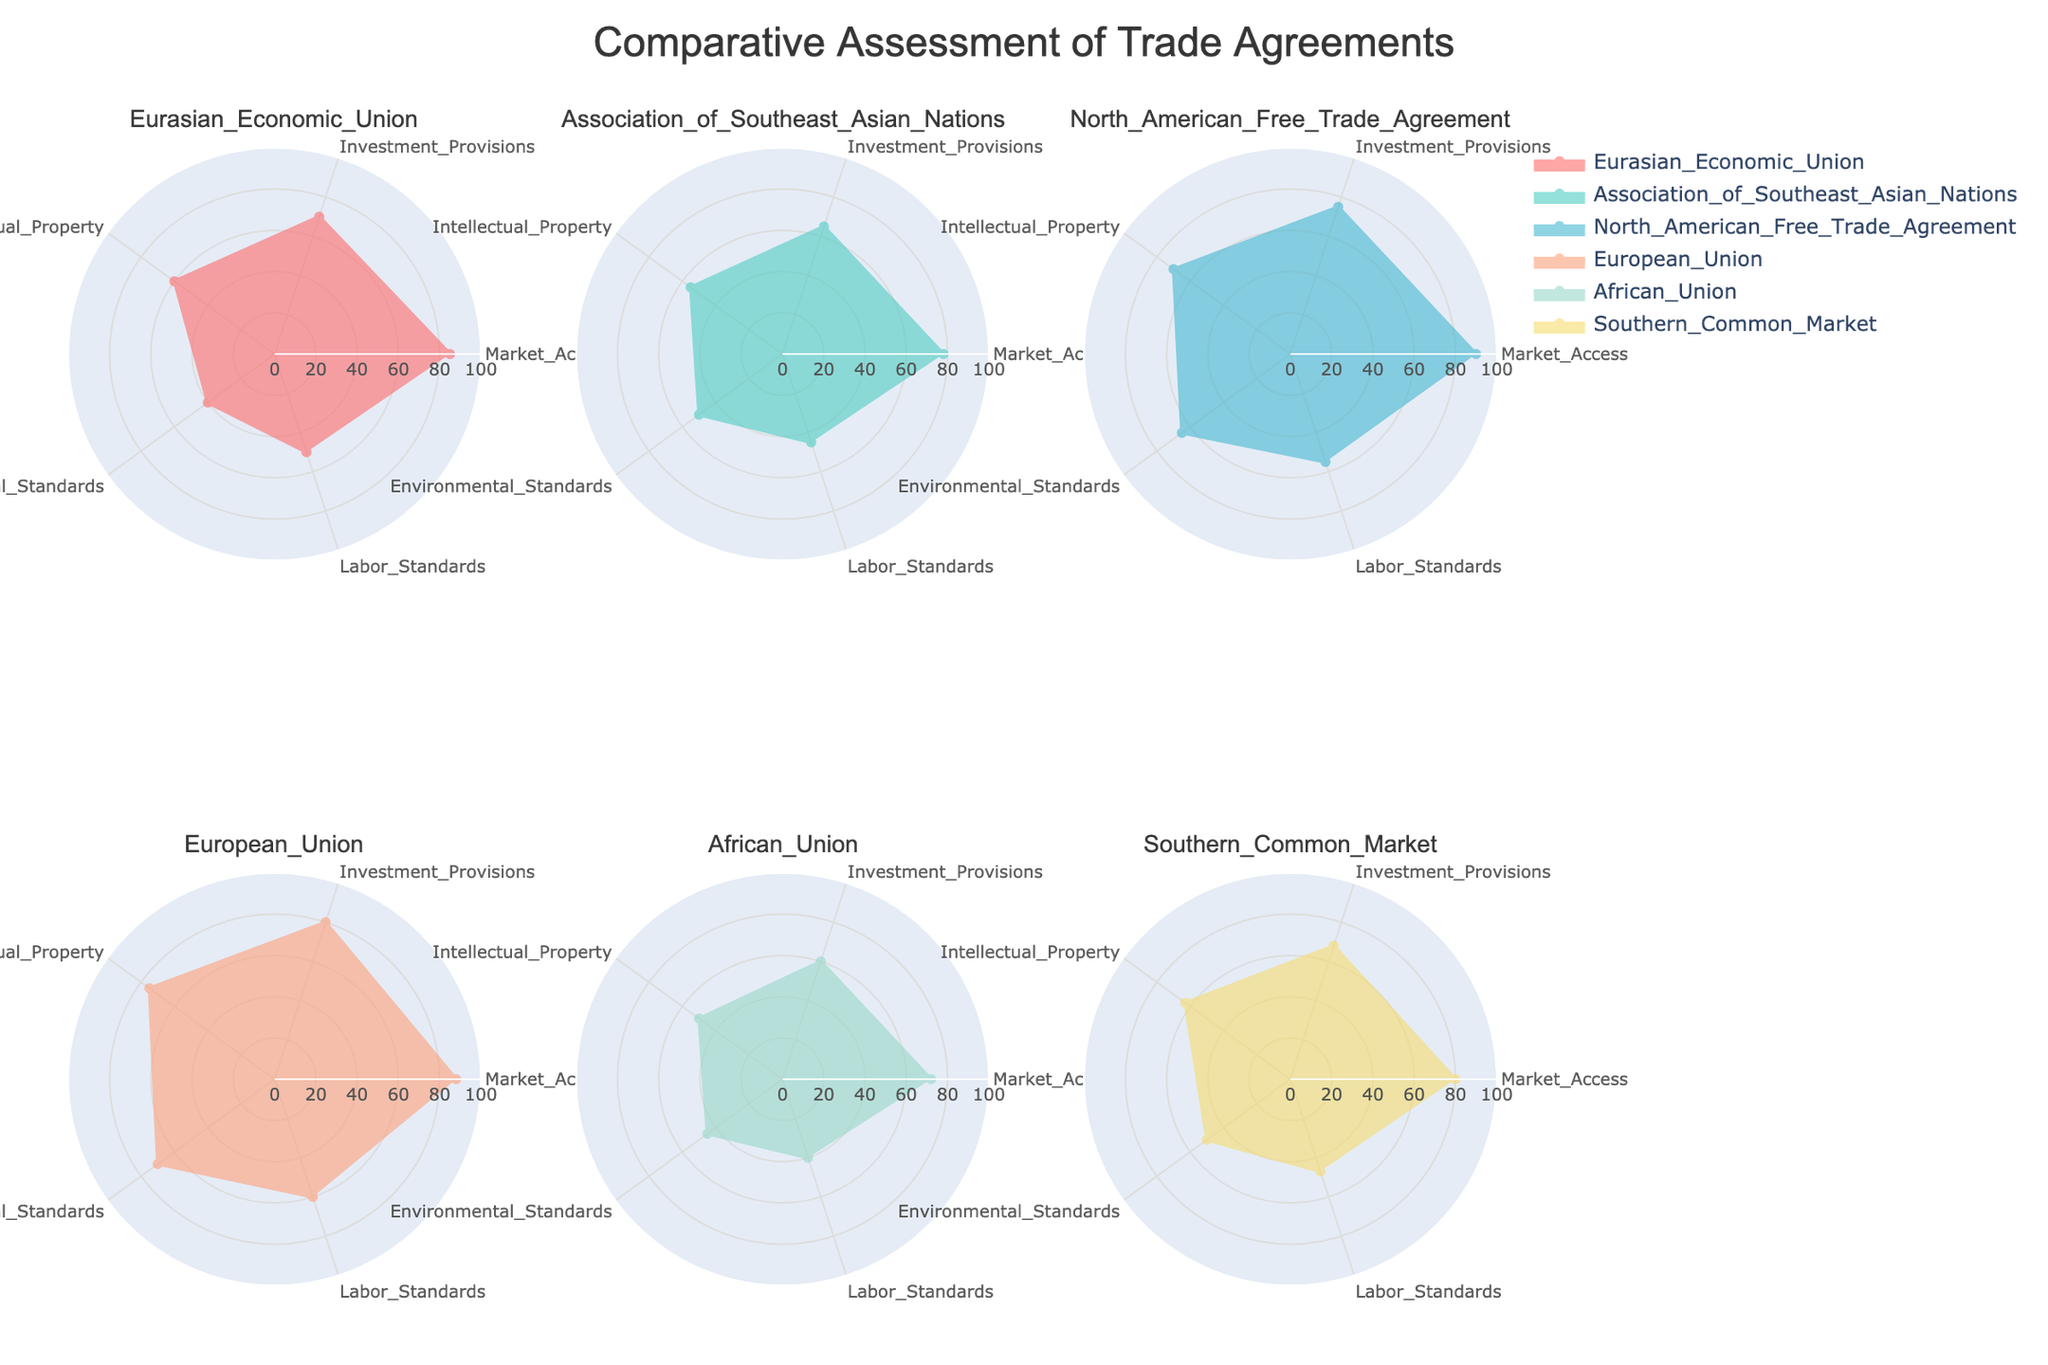What is the highest market access value observed among the trade agreements? To determine the highest market access value, we look at the "Market Access" values in each radar chart. The values are: EEU (85), ASEAN (78), NAFTA (90), EU (88), AU (72), MERCOSUR (80). The highest value is 90 from NAFTA.
Answer: 90 Which trade agreement has the lowest labor standards? To find the lowest labor standards, we check the "Labor Standards" values in each radar chart. The values are: EEU (50), ASEAN (45), NAFTA (55), EU (60), AU (40), MERCOSUR (47). The lowest value is 40 from the AU.
Answer: AU What is the average environmental standards score across all trade agreements? To find the average environmental standards score, we sum up the "Environmental Standards" values and divide by the number of trade agreements: (40 + 50 + 65 + 70 + 45 + 50) / 6 = 320 / 6 = 53.33.
Answer: 53.33 Compare the investment provisions between the European Union and the Eurasian Economic Union. Which one is higher and by how much? The investment provisions for the EU is 80, and for the EEU is 70. The difference is 80 - 70 = 10. The EU's investment provisions are higher by 10.
Answer: EU by 10 Which two economic blocs have the closest scores in intellectual property rights? To find the closest scores in intellectual property rights, we compare the values: EEU (60), ASEAN (55), NAFTA (70), EU (75), AU (50), MERCOSUR (63). The closest pair is ASEAN (55) and EEU (60) with a difference of 5.
Answer: ASEAN and EEU Which trade agreement has the most balanced scores across all categories? To determine the most balanced scores, we look for the trade agreement with the smallest range among its values (difference between highest and lowest score). EEU: 85-40=45, ASEAN: 78-45=33, NAFTA: 90-55=35, EU: 88-60=28, AU: 72-40=32, MERCOSUR: 80-47=33. The EU has the smallest range, indicating the most balanced scores.
Answer: EU In which category does the North American Free Trade Agreement (NAFTA) lead? By examining the radar chart for NAFTA, we see that NAFTA leads in "Market Access" with a score of 90, which is the highest among all trade agreements.
Answer: Market Access 